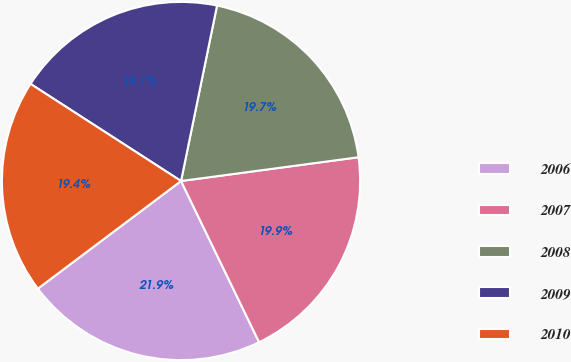Convert chart. <chart><loc_0><loc_0><loc_500><loc_500><pie_chart><fcel>2006<fcel>2007<fcel>2008<fcel>2009<fcel>2010<nl><fcel>21.92%<fcel>19.94%<fcel>19.66%<fcel>19.1%<fcel>19.38%<nl></chart> 